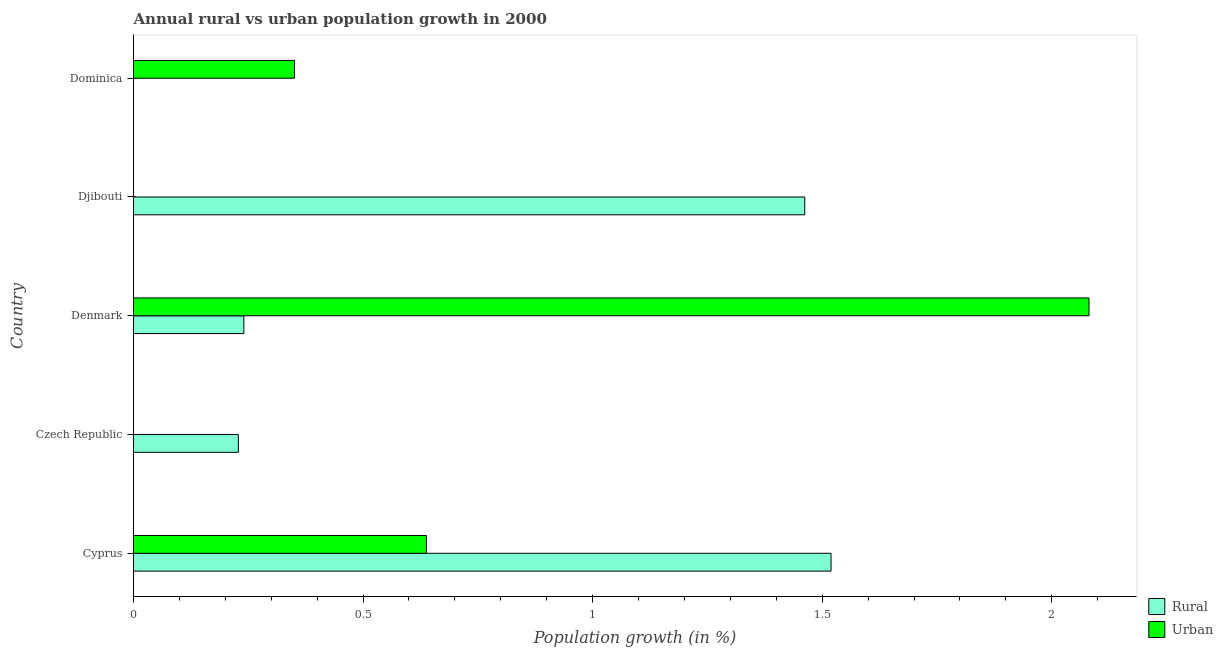How many bars are there on the 1st tick from the bottom?
Offer a terse response. 2. What is the label of the 1st group of bars from the top?
Your answer should be compact. Dominica. What is the rural population growth in Cyprus?
Provide a short and direct response. 1.52. Across all countries, what is the maximum urban population growth?
Your response must be concise. 2.08. In which country was the urban population growth maximum?
Make the answer very short. Denmark. What is the total urban population growth in the graph?
Your response must be concise. 3.07. What is the difference between the rural population growth in Czech Republic and that in Denmark?
Ensure brevity in your answer.  -0.01. What is the difference between the urban population growth in Djibouti and the rural population growth in Dominica?
Offer a very short reply. 0. What is the average urban population growth per country?
Ensure brevity in your answer.  0.61. What is the difference between the urban population growth and rural population growth in Cyprus?
Ensure brevity in your answer.  -0.88. In how many countries, is the rural population growth greater than 1.6 %?
Your answer should be very brief. 0. What is the ratio of the urban population growth in Denmark to that in Dominica?
Provide a succinct answer. 5.93. What is the difference between the highest and the second highest rural population growth?
Ensure brevity in your answer.  0.06. What is the difference between the highest and the lowest urban population growth?
Your answer should be very brief. 2.08. In how many countries, is the urban population growth greater than the average urban population growth taken over all countries?
Your answer should be compact. 2. Is the sum of the urban population growth in Cyprus and Dominica greater than the maximum rural population growth across all countries?
Your response must be concise. No. How many bars are there?
Provide a succinct answer. 7. How many countries are there in the graph?
Make the answer very short. 5. Does the graph contain any zero values?
Provide a succinct answer. Yes. Does the graph contain grids?
Give a very brief answer. No. Where does the legend appear in the graph?
Keep it short and to the point. Bottom right. How many legend labels are there?
Provide a short and direct response. 2. How are the legend labels stacked?
Keep it short and to the point. Vertical. What is the title of the graph?
Provide a succinct answer. Annual rural vs urban population growth in 2000. What is the label or title of the X-axis?
Your answer should be very brief. Population growth (in %). What is the label or title of the Y-axis?
Your answer should be very brief. Country. What is the Population growth (in %) in Rural in Cyprus?
Ensure brevity in your answer.  1.52. What is the Population growth (in %) in Urban  in Cyprus?
Your answer should be very brief. 0.64. What is the Population growth (in %) in Rural in Czech Republic?
Offer a terse response. 0.23. What is the Population growth (in %) in Urban  in Czech Republic?
Offer a very short reply. 0. What is the Population growth (in %) in Rural in Denmark?
Provide a succinct answer. 0.24. What is the Population growth (in %) in Urban  in Denmark?
Ensure brevity in your answer.  2.08. What is the Population growth (in %) in Rural in Djibouti?
Offer a very short reply. 1.46. What is the Population growth (in %) of Urban  in Dominica?
Provide a succinct answer. 0.35. Across all countries, what is the maximum Population growth (in %) of Rural?
Your answer should be compact. 1.52. Across all countries, what is the maximum Population growth (in %) in Urban ?
Provide a succinct answer. 2.08. Across all countries, what is the minimum Population growth (in %) of Rural?
Offer a very short reply. 0. Across all countries, what is the minimum Population growth (in %) in Urban ?
Make the answer very short. 0. What is the total Population growth (in %) of Rural in the graph?
Your response must be concise. 3.45. What is the total Population growth (in %) in Urban  in the graph?
Make the answer very short. 3.07. What is the difference between the Population growth (in %) in Rural in Cyprus and that in Czech Republic?
Provide a succinct answer. 1.29. What is the difference between the Population growth (in %) in Rural in Cyprus and that in Denmark?
Offer a very short reply. 1.28. What is the difference between the Population growth (in %) in Urban  in Cyprus and that in Denmark?
Provide a short and direct response. -1.44. What is the difference between the Population growth (in %) in Rural in Cyprus and that in Djibouti?
Your answer should be very brief. 0.06. What is the difference between the Population growth (in %) in Urban  in Cyprus and that in Dominica?
Your response must be concise. 0.29. What is the difference between the Population growth (in %) in Rural in Czech Republic and that in Denmark?
Make the answer very short. -0.01. What is the difference between the Population growth (in %) of Rural in Czech Republic and that in Djibouti?
Offer a terse response. -1.23. What is the difference between the Population growth (in %) in Rural in Denmark and that in Djibouti?
Provide a succinct answer. -1.22. What is the difference between the Population growth (in %) in Urban  in Denmark and that in Dominica?
Your answer should be compact. 1.73. What is the difference between the Population growth (in %) in Rural in Cyprus and the Population growth (in %) in Urban  in Denmark?
Make the answer very short. -0.56. What is the difference between the Population growth (in %) of Rural in Cyprus and the Population growth (in %) of Urban  in Dominica?
Provide a short and direct response. 1.17. What is the difference between the Population growth (in %) of Rural in Czech Republic and the Population growth (in %) of Urban  in Denmark?
Keep it short and to the point. -1.85. What is the difference between the Population growth (in %) in Rural in Czech Republic and the Population growth (in %) in Urban  in Dominica?
Keep it short and to the point. -0.12. What is the difference between the Population growth (in %) of Rural in Denmark and the Population growth (in %) of Urban  in Dominica?
Keep it short and to the point. -0.11. What is the difference between the Population growth (in %) in Rural in Djibouti and the Population growth (in %) in Urban  in Dominica?
Offer a terse response. 1.11. What is the average Population growth (in %) of Rural per country?
Your response must be concise. 0.69. What is the average Population growth (in %) in Urban  per country?
Provide a short and direct response. 0.61. What is the difference between the Population growth (in %) of Rural and Population growth (in %) of Urban  in Cyprus?
Your response must be concise. 0.88. What is the difference between the Population growth (in %) in Rural and Population growth (in %) in Urban  in Denmark?
Keep it short and to the point. -1.84. What is the ratio of the Population growth (in %) in Rural in Cyprus to that in Czech Republic?
Offer a terse response. 6.65. What is the ratio of the Population growth (in %) of Rural in Cyprus to that in Denmark?
Give a very brief answer. 6.32. What is the ratio of the Population growth (in %) of Urban  in Cyprus to that in Denmark?
Provide a short and direct response. 0.31. What is the ratio of the Population growth (in %) in Rural in Cyprus to that in Djibouti?
Provide a succinct answer. 1.04. What is the ratio of the Population growth (in %) in Urban  in Cyprus to that in Dominica?
Your answer should be very brief. 1.82. What is the ratio of the Population growth (in %) in Rural in Czech Republic to that in Denmark?
Offer a terse response. 0.95. What is the ratio of the Population growth (in %) in Rural in Czech Republic to that in Djibouti?
Make the answer very short. 0.16. What is the ratio of the Population growth (in %) of Rural in Denmark to that in Djibouti?
Your response must be concise. 0.16. What is the ratio of the Population growth (in %) in Urban  in Denmark to that in Dominica?
Keep it short and to the point. 5.93. What is the difference between the highest and the second highest Population growth (in %) in Rural?
Offer a terse response. 0.06. What is the difference between the highest and the second highest Population growth (in %) of Urban ?
Give a very brief answer. 1.44. What is the difference between the highest and the lowest Population growth (in %) of Rural?
Offer a terse response. 1.52. What is the difference between the highest and the lowest Population growth (in %) of Urban ?
Provide a short and direct response. 2.08. 